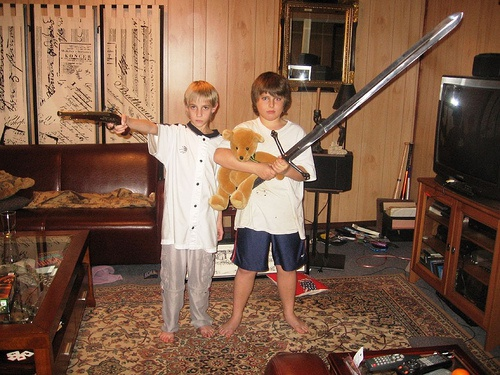Describe the objects in this image and their specific colors. I can see couch in maroon, black, and brown tones, people in maroon, white, darkgray, gray, and tan tones, people in maroon, ivory, salmon, and black tones, tv in maroon, black, gray, and lightgray tones, and teddy bear in maroon, tan, and orange tones in this image. 